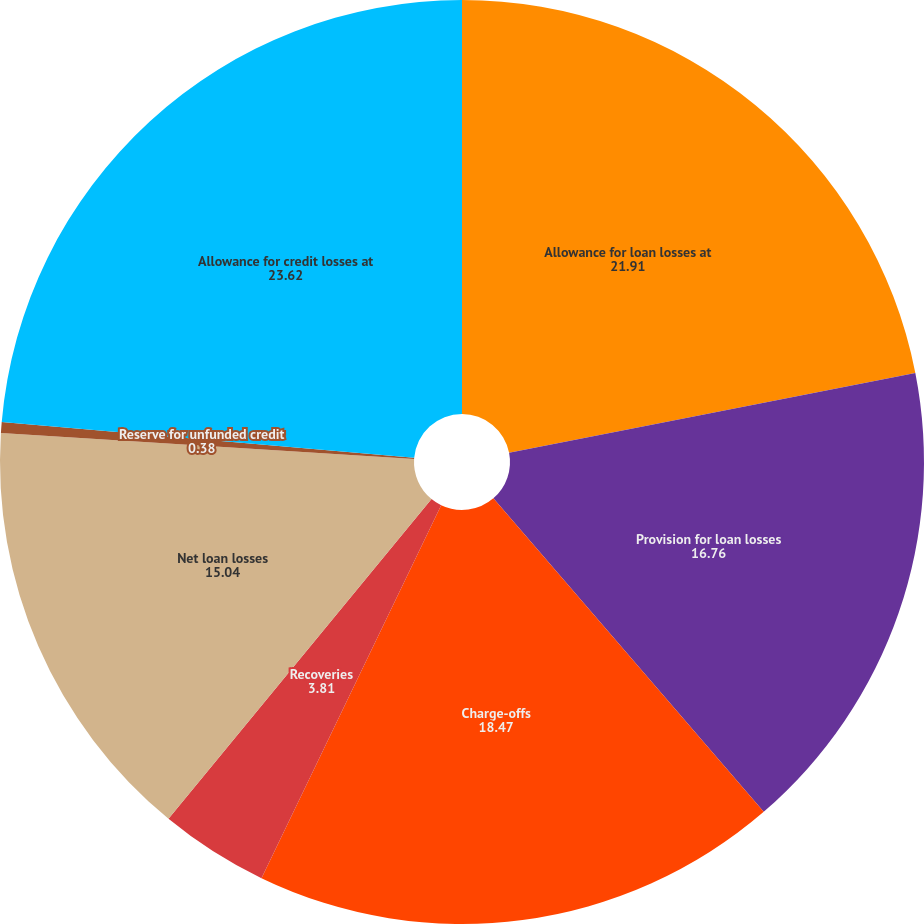Convert chart to OTSL. <chart><loc_0><loc_0><loc_500><loc_500><pie_chart><fcel>Allowance for loan losses at<fcel>Provision for loan losses<fcel>Charge-offs<fcel>Recoveries<fcel>Net loan losses<fcel>Reserve for unfunded credit<fcel>Allowance for credit losses at<nl><fcel>21.91%<fcel>16.76%<fcel>18.47%<fcel>3.81%<fcel>15.04%<fcel>0.38%<fcel>23.62%<nl></chart> 